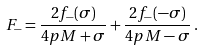<formula> <loc_0><loc_0><loc_500><loc_500>F _ { - } = \frac { 2 f _ { - } ( \sigma ) } { 4 p M + \sigma } + \frac { 2 f _ { - } ( - \sigma ) } { 4 p M - \sigma } \, .</formula> 